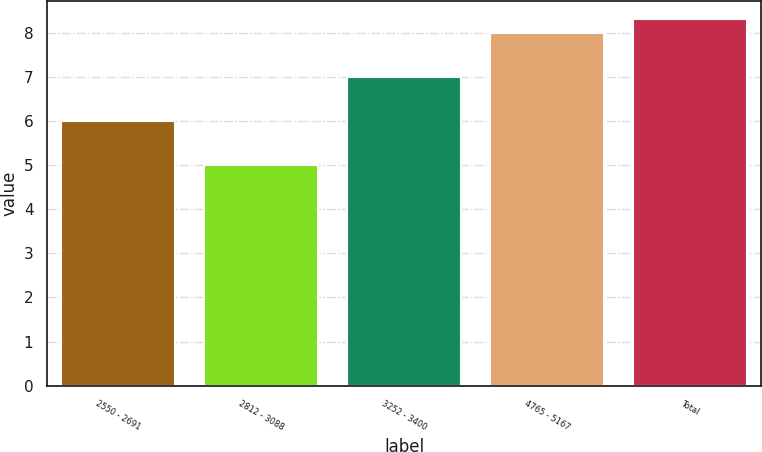Convert chart. <chart><loc_0><loc_0><loc_500><loc_500><bar_chart><fcel>2550 - 2691<fcel>2812 - 3088<fcel>3252 - 3400<fcel>4765 - 5167<fcel>Total<nl><fcel>6<fcel>5<fcel>7<fcel>8<fcel>8.3<nl></chart> 